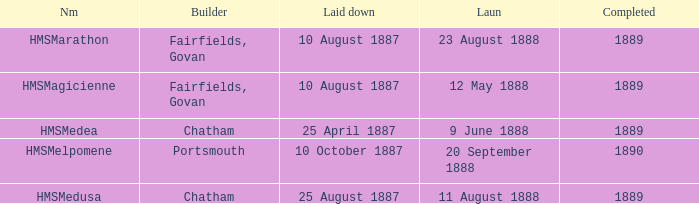Which constructor finished after 1889? Portsmouth. 